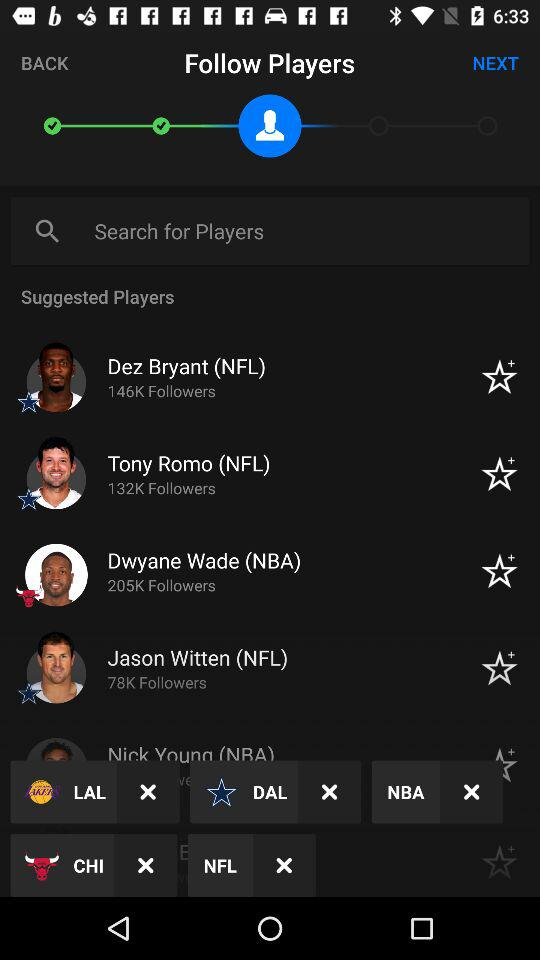How many players have more than 100K followers?
Answer the question using a single word or phrase. 3 